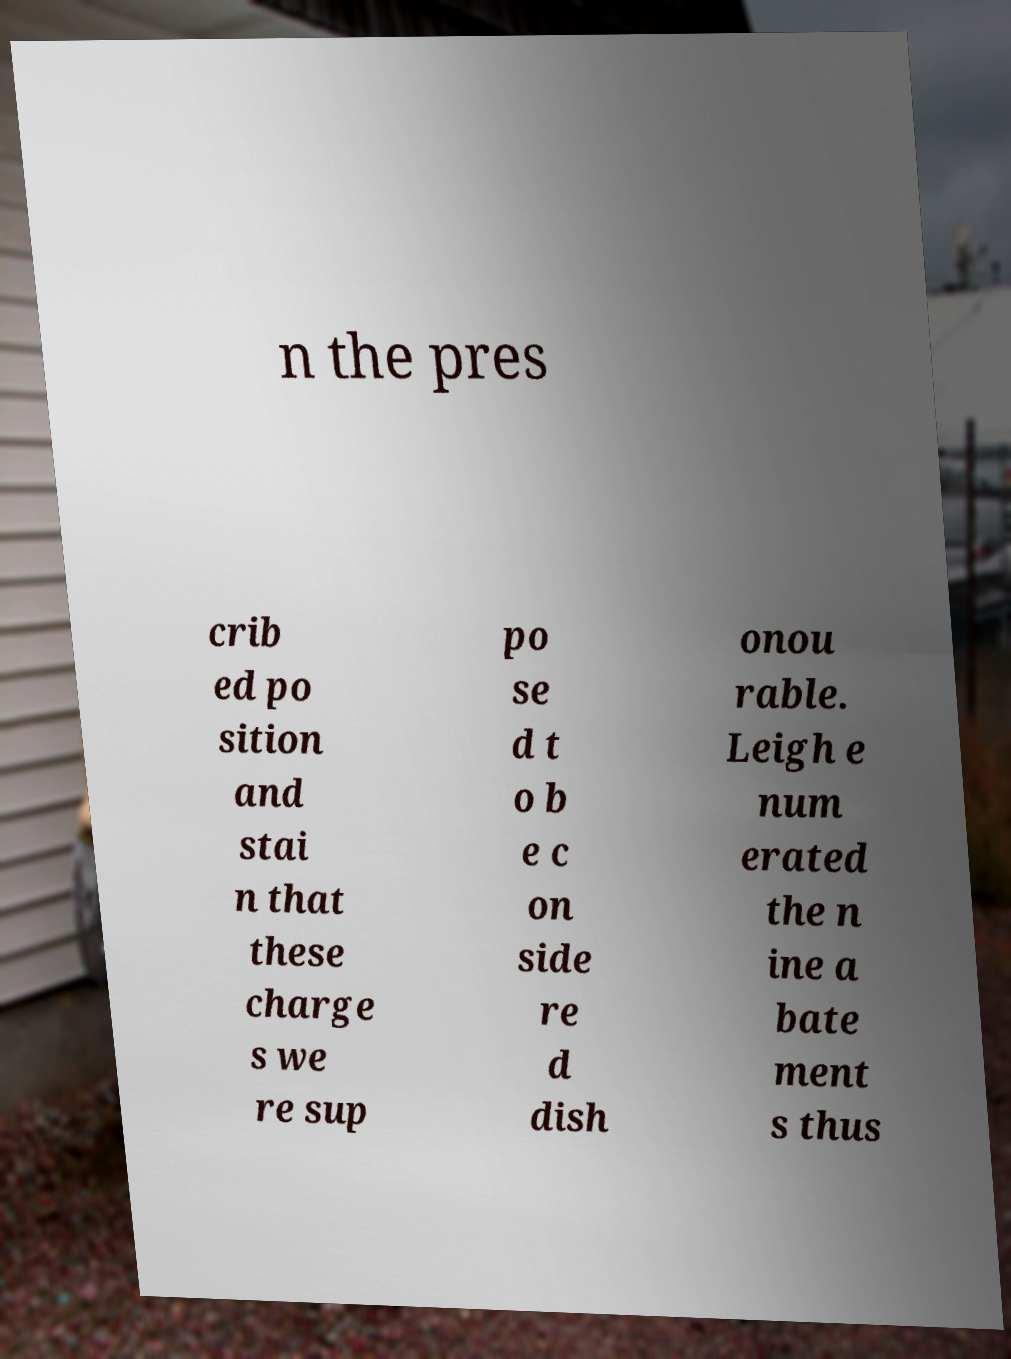What messages or text are displayed in this image? I need them in a readable, typed format. n the pres crib ed po sition and stai n that these charge s we re sup po se d t o b e c on side re d dish onou rable. Leigh e num erated the n ine a bate ment s thus 